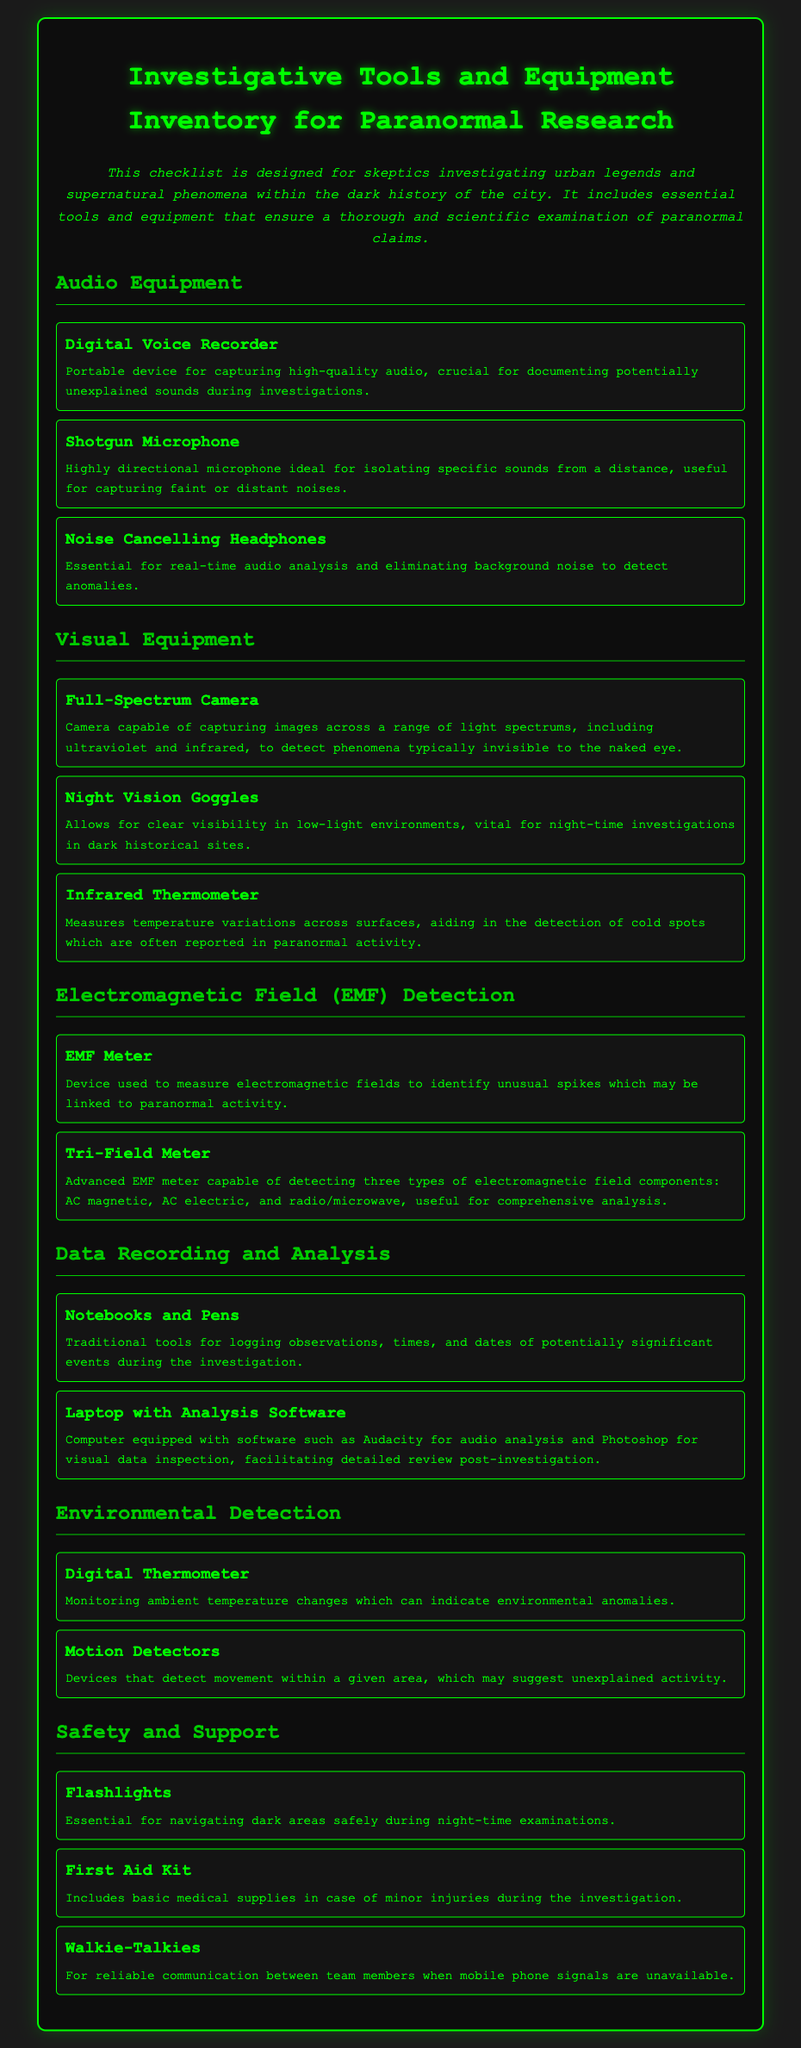What is the purpose of the checklist? The checklist is designed for skeptics investigating urban legends and supernatural phenomena within the dark history of the city.
Answer: Investigative tools and equipment inventory for paranormal research How many types of audio equipment are listed? The document lists three specific types of audio equipment under the section titled "Audio Equipment."
Answer: Three What does the full-spectrum camera capture? It captures images across a range of light spectrums, including ultraviolet and infrared.
Answer: Light spectrums including ultraviolet and infrared What is the function of the EMF Meter? The EMF Meter is used to measure electromagnetic fields to identify unusual spikes.
Answer: Measure electromagnetic fields Which item is required for reliable communication? Walkie-Talkies are mentioned as necessary for communication between team members.
Answer: Walkie-Talkies What basic supplies are included in the first aid kit? The first aid kit includes basic medical supplies in case of minor injuries during the investigation.
Answer: Basic medical supplies 